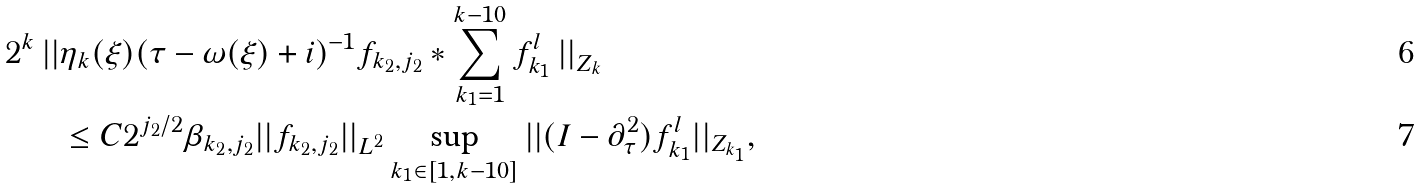<formula> <loc_0><loc_0><loc_500><loc_500>2 ^ { k } \left | \right | & \eta _ { k } ( \xi ) ( \tau - \omega ( \xi ) + i ) ^ { - 1 } f _ { k _ { 2 } , j _ { 2 } } \ast \sum _ { k _ { 1 } = 1 } ^ { k - 1 0 } f _ { k _ { 1 } } ^ { l } \left | \right | _ { Z _ { k } } \\ & \leq C 2 ^ { j _ { 2 } / 2 } \beta _ { k _ { 2 } , j _ { 2 } } | | f _ { k _ { 2 } , j _ { 2 } } | | _ { L ^ { 2 } } \sup _ { k _ { 1 } \in [ 1 , k - 1 0 ] } | | ( I - \partial _ { \tau } ^ { 2 } ) f _ { k _ { 1 } } ^ { l } | | _ { Z _ { k _ { 1 } } } ,</formula> 